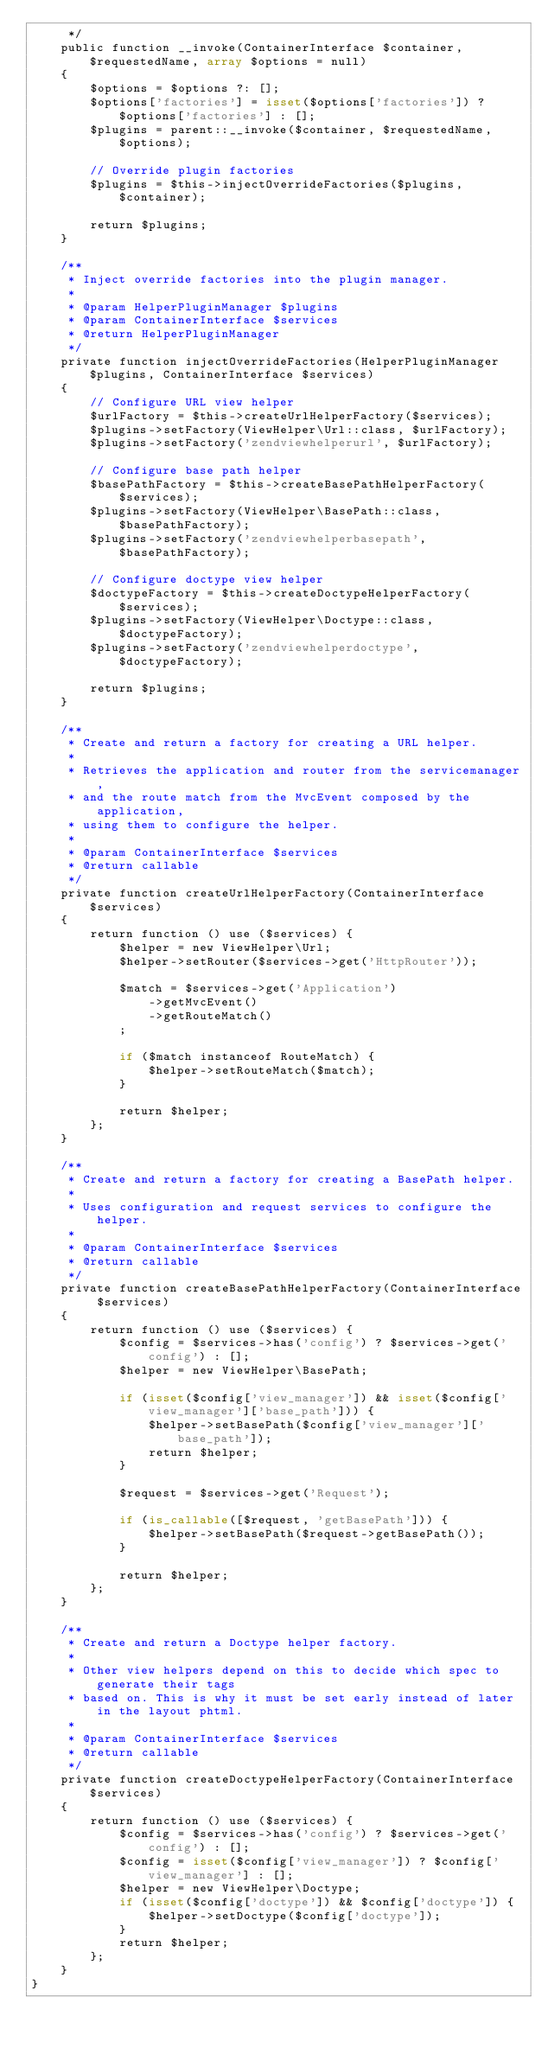<code> <loc_0><loc_0><loc_500><loc_500><_PHP_>     */
    public function __invoke(ContainerInterface $container, $requestedName, array $options = null)
    {
        $options = $options ?: [];
        $options['factories'] = isset($options['factories']) ? $options['factories'] : [];
        $plugins = parent::__invoke($container, $requestedName, $options);

        // Override plugin factories
        $plugins = $this->injectOverrideFactories($plugins, $container);

        return $plugins;
    }

    /**
     * Inject override factories into the plugin manager.
     *
     * @param HelperPluginManager $plugins
     * @param ContainerInterface $services
     * @return HelperPluginManager
     */
    private function injectOverrideFactories(HelperPluginManager $plugins, ContainerInterface $services)
    {
        // Configure URL view helper
        $urlFactory = $this->createUrlHelperFactory($services);
        $plugins->setFactory(ViewHelper\Url::class, $urlFactory);
        $plugins->setFactory('zendviewhelperurl', $urlFactory);

        // Configure base path helper
        $basePathFactory = $this->createBasePathHelperFactory($services);
        $plugins->setFactory(ViewHelper\BasePath::class, $basePathFactory);
        $plugins->setFactory('zendviewhelperbasepath', $basePathFactory);

        // Configure doctype view helper
        $doctypeFactory = $this->createDoctypeHelperFactory($services);
        $plugins->setFactory(ViewHelper\Doctype::class, $doctypeFactory);
        $plugins->setFactory('zendviewhelperdoctype', $doctypeFactory);

        return $plugins;
    }

    /**
     * Create and return a factory for creating a URL helper.
     *
     * Retrieves the application and router from the servicemanager,
     * and the route match from the MvcEvent composed by the application,
     * using them to configure the helper.
     *
     * @param ContainerInterface $services
     * @return callable
     */
    private function createUrlHelperFactory(ContainerInterface $services)
    {
        return function () use ($services) {
            $helper = new ViewHelper\Url;
            $helper->setRouter($services->get('HttpRouter'));

            $match = $services->get('Application')
                ->getMvcEvent()
                ->getRouteMatch()
            ;

            if ($match instanceof RouteMatch) {
                $helper->setRouteMatch($match);
            }

            return $helper;
        };
    }

    /**
     * Create and return a factory for creating a BasePath helper.
     *
     * Uses configuration and request services to configure the helper.
     *
     * @param ContainerInterface $services
     * @return callable
     */
    private function createBasePathHelperFactory(ContainerInterface $services)
    {
        return function () use ($services) {
            $config = $services->has('config') ? $services->get('config') : [];
            $helper = new ViewHelper\BasePath;

            if (isset($config['view_manager']) && isset($config['view_manager']['base_path'])) {
                $helper->setBasePath($config['view_manager']['base_path']);
                return $helper;
            }

            $request = $services->get('Request');

            if (is_callable([$request, 'getBasePath'])) {
                $helper->setBasePath($request->getBasePath());
            }

            return $helper;
        };
    }

    /**
     * Create and return a Doctype helper factory.
     *
     * Other view helpers depend on this to decide which spec to generate their tags
     * based on. This is why it must be set early instead of later in the layout phtml.
     *
     * @param ContainerInterface $services
     * @return callable
     */
    private function createDoctypeHelperFactory(ContainerInterface $services)
    {
        return function () use ($services) {
            $config = $services->has('config') ? $services->get('config') : [];
            $config = isset($config['view_manager']) ? $config['view_manager'] : [];
            $helper = new ViewHelper\Doctype;
            if (isset($config['doctype']) && $config['doctype']) {
                $helper->setDoctype($config['doctype']);
            }
            return $helper;
        };
    }
}
</code> 